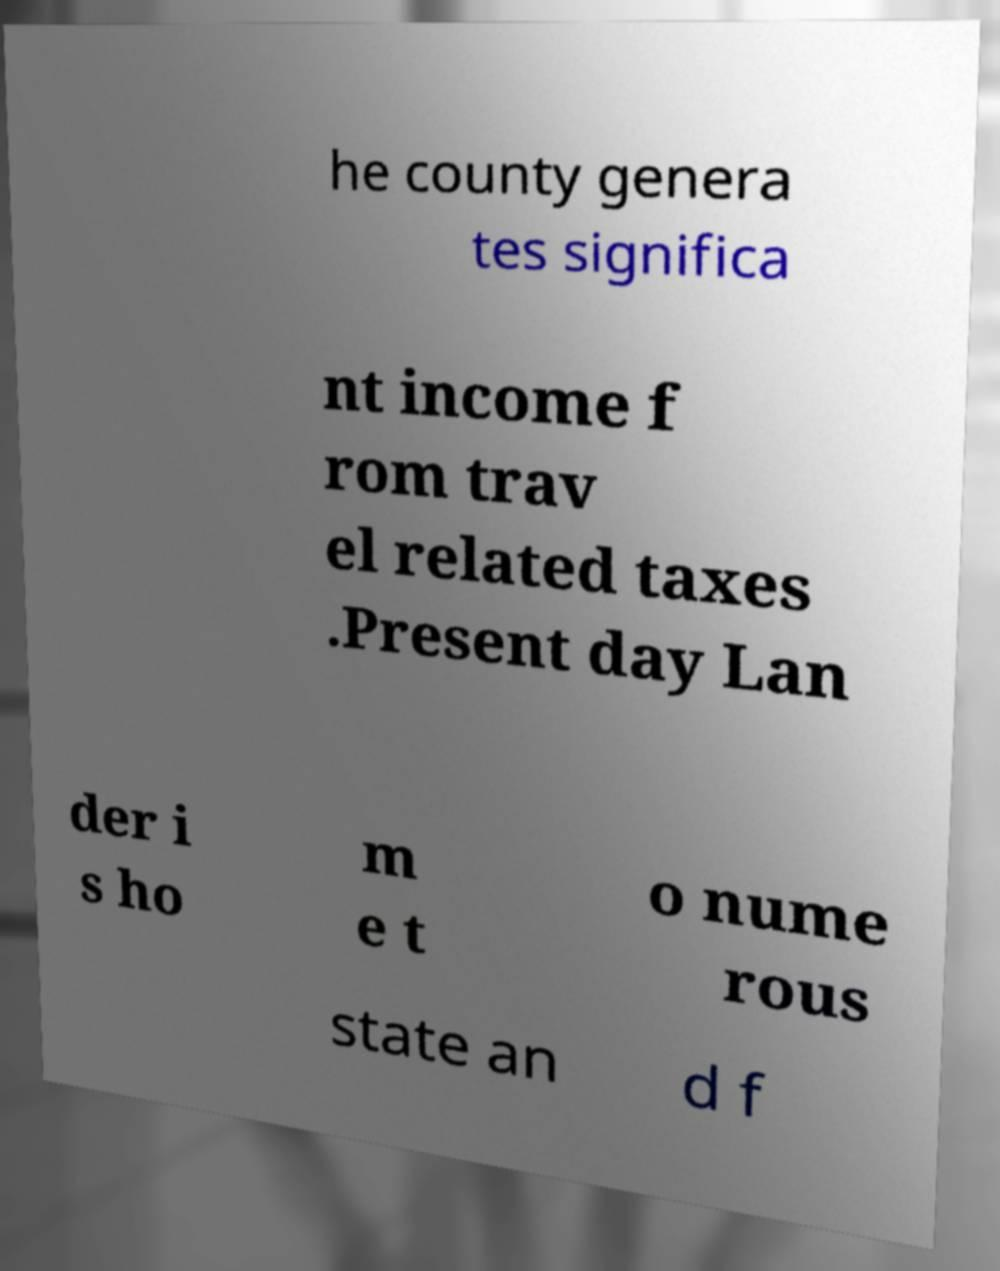There's text embedded in this image that I need extracted. Can you transcribe it verbatim? he county genera tes significa nt income f rom trav el related taxes .Present day Lan der i s ho m e t o nume rous state an d f 